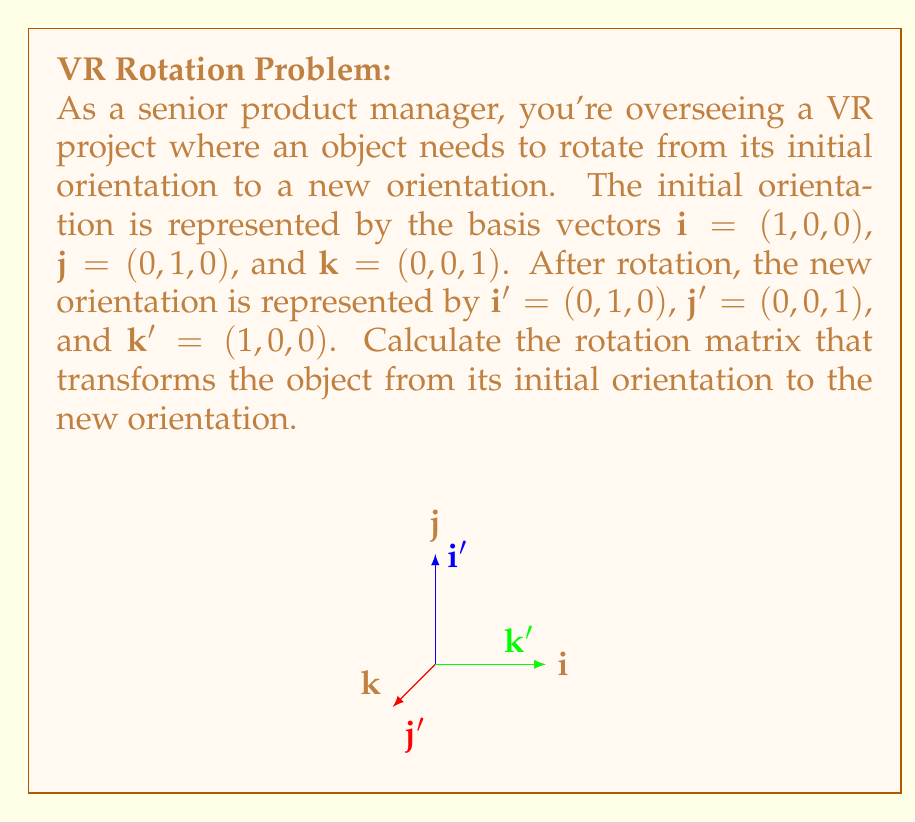Help me with this question. To calculate the rotation matrix, we'll follow these steps:

1) The rotation matrix $R$ is a 3x3 matrix that transforms the initial basis vectors to the new basis vectors:

   $$R \cdot \begin{bmatrix} \mathbf{i} & \mathbf{j} & \mathbf{k} \end{bmatrix} = \begin{bmatrix} \mathbf{i'} & \mathbf{j'} & \mathbf{k'} \end{bmatrix}$$

2) We can write this as:

   $$R \cdot \begin{bmatrix} 1 & 0 & 0 \\ 0 & 1 & 0 \\ 0 & 0 & 1 \end{bmatrix} = \begin{bmatrix} 0 & 0 & 1 \\ 1 & 0 & 0 \\ 0 & 1 & 0 \end{bmatrix}$$

3) The right-hand side of this equation is actually our rotation matrix $R$, because multiplying it by the identity matrix on the left doesn't change it.

4) Therefore, the rotation matrix $R$ is:

   $$R = \begin{bmatrix} 0 & 0 & 1 \\ 1 & 0 & 0 \\ 0 & 1 & 0 \end{bmatrix}$$

5) To verify, we can check that this matrix correctly transforms each basis vector:

   $$R \cdot \mathbf{i} = \begin{bmatrix} 0 & 0 & 1 \\ 1 & 0 & 0 \\ 0 & 1 & 0 \end{bmatrix} \cdot \begin{bmatrix} 1 \\ 0 \\ 0 \end{bmatrix} = \begin{bmatrix} 0 \\ 1 \\ 0 \end{bmatrix} = \mathbf{i'}$$

   $$R \cdot \mathbf{j} = \begin{bmatrix} 0 & 0 & 1 \\ 1 & 0 & 0 \\ 0 & 1 & 0 \end{bmatrix} \cdot \begin{bmatrix} 0 \\ 1 \\ 0 \end{bmatrix} = \begin{bmatrix} 0 \\ 0 \\ 1 \end{bmatrix} = \mathbf{j'}$$

   $$R \cdot \mathbf{k} = \begin{bmatrix} 0 & 0 & 1 \\ 1 & 0 & 0 \\ 0 & 1 & 0 \end{bmatrix} \cdot \begin{bmatrix} 0 \\ 0 \\ 1 \end{bmatrix} = \begin{bmatrix} 1 \\ 0 \\ 0 \end{bmatrix} = \mathbf{k'}$$

This confirms that our rotation matrix is correct.
Answer: $$R = \begin{bmatrix} 0 & 0 & 1 \\ 1 & 0 & 0 \\ 0 & 1 & 0 \end{bmatrix}$$ 